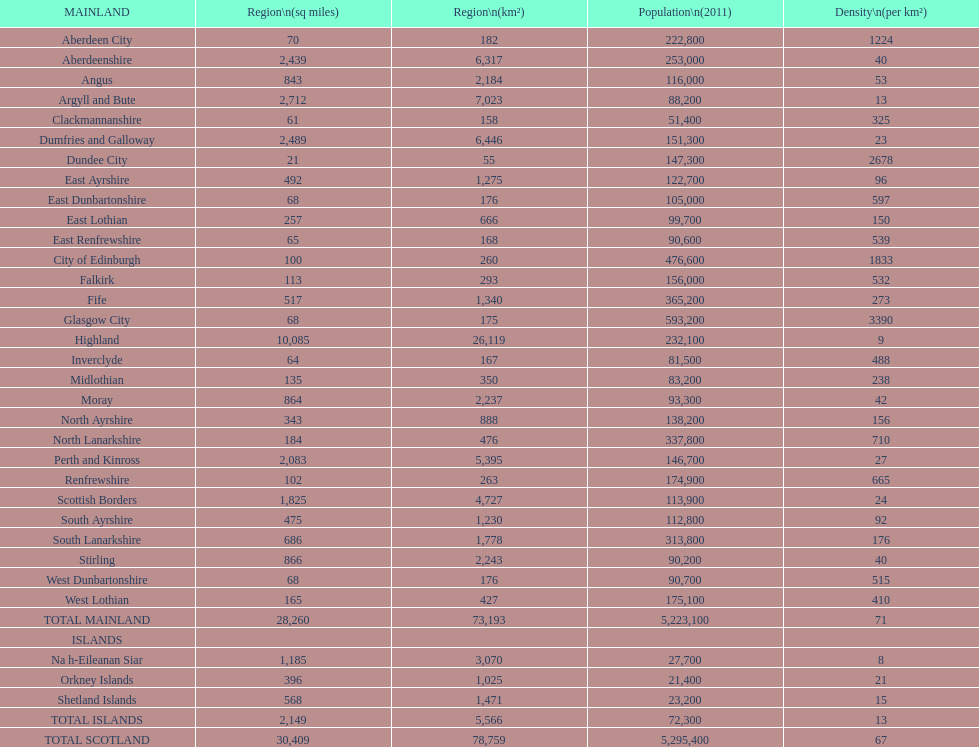What is the average population density in mainland cities? 71. 